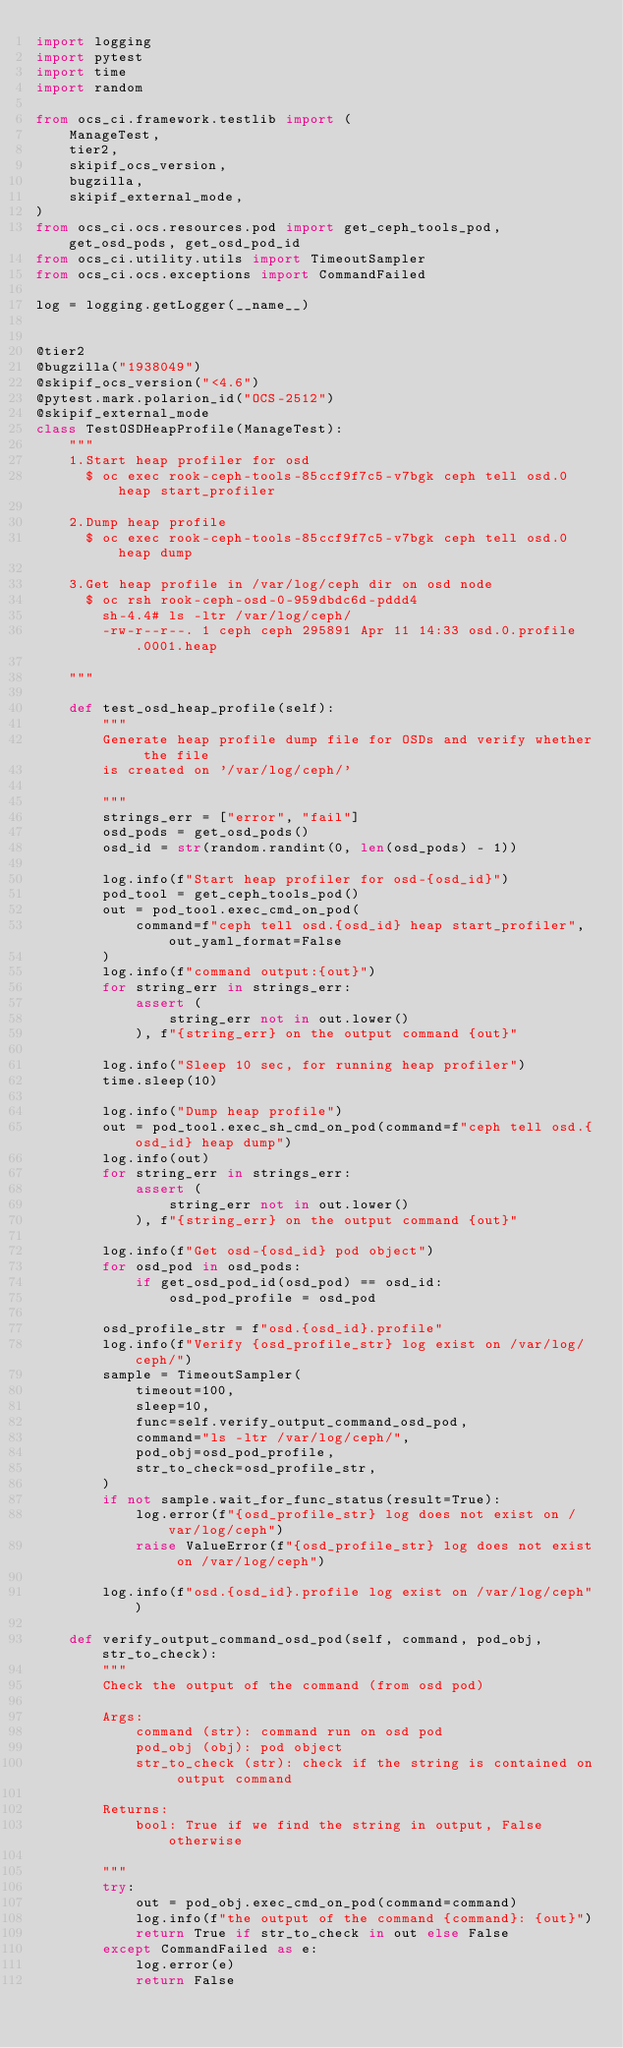<code> <loc_0><loc_0><loc_500><loc_500><_Python_>import logging
import pytest
import time
import random

from ocs_ci.framework.testlib import (
    ManageTest,
    tier2,
    skipif_ocs_version,
    bugzilla,
    skipif_external_mode,
)
from ocs_ci.ocs.resources.pod import get_ceph_tools_pod, get_osd_pods, get_osd_pod_id
from ocs_ci.utility.utils import TimeoutSampler
from ocs_ci.ocs.exceptions import CommandFailed

log = logging.getLogger(__name__)


@tier2
@bugzilla("1938049")
@skipif_ocs_version("<4.6")
@pytest.mark.polarion_id("OCS-2512")
@skipif_external_mode
class TestOSDHeapProfile(ManageTest):
    """
    1.Start heap profiler for osd
      $ oc exec rook-ceph-tools-85ccf9f7c5-v7bgk ceph tell osd.0 heap start_profiler

    2.Dump heap profile
      $ oc exec rook-ceph-tools-85ccf9f7c5-v7bgk ceph tell osd.0 heap dump

    3.Get heap profile in /var/log/ceph dir on osd node
      $ oc rsh rook-ceph-osd-0-959dbdc6d-pddd4
        sh-4.4# ls -ltr /var/log/ceph/
        -rw-r--r--. 1 ceph ceph 295891 Apr 11 14:33 osd.0.profile.0001.heap

    """

    def test_osd_heap_profile(self):
        """
        Generate heap profile dump file for OSDs and verify whether the file
        is created on '/var/log/ceph/'

        """
        strings_err = ["error", "fail"]
        osd_pods = get_osd_pods()
        osd_id = str(random.randint(0, len(osd_pods) - 1))

        log.info(f"Start heap profiler for osd-{osd_id}")
        pod_tool = get_ceph_tools_pod()
        out = pod_tool.exec_cmd_on_pod(
            command=f"ceph tell osd.{osd_id} heap start_profiler", out_yaml_format=False
        )
        log.info(f"command output:{out}")
        for string_err in strings_err:
            assert (
                string_err not in out.lower()
            ), f"{string_err} on the output command {out}"

        log.info("Sleep 10 sec, for running heap profiler")
        time.sleep(10)

        log.info("Dump heap profile")
        out = pod_tool.exec_sh_cmd_on_pod(command=f"ceph tell osd.{osd_id} heap dump")
        log.info(out)
        for string_err in strings_err:
            assert (
                string_err not in out.lower()
            ), f"{string_err} on the output command {out}"

        log.info(f"Get osd-{osd_id} pod object")
        for osd_pod in osd_pods:
            if get_osd_pod_id(osd_pod) == osd_id:
                osd_pod_profile = osd_pod

        osd_profile_str = f"osd.{osd_id}.profile"
        log.info(f"Verify {osd_profile_str} log exist on /var/log/ceph/")
        sample = TimeoutSampler(
            timeout=100,
            sleep=10,
            func=self.verify_output_command_osd_pod,
            command="ls -ltr /var/log/ceph/",
            pod_obj=osd_pod_profile,
            str_to_check=osd_profile_str,
        )
        if not sample.wait_for_func_status(result=True):
            log.error(f"{osd_profile_str} log does not exist on /var/log/ceph")
            raise ValueError(f"{osd_profile_str} log does not exist on /var/log/ceph")

        log.info(f"osd.{osd_id}.profile log exist on /var/log/ceph")

    def verify_output_command_osd_pod(self, command, pod_obj, str_to_check):
        """
        Check the output of the command (from osd pod)

        Args:
            command (str): command run on osd pod
            pod_obj (obj): pod object
            str_to_check (str): check if the string is contained on output command

        Returns:
            bool: True if we find the string in output, False otherwise

        """
        try:
            out = pod_obj.exec_cmd_on_pod(command=command)
            log.info(f"the output of the command {command}: {out}")
            return True if str_to_check in out else False
        except CommandFailed as e:
            log.error(e)
            return False
</code> 